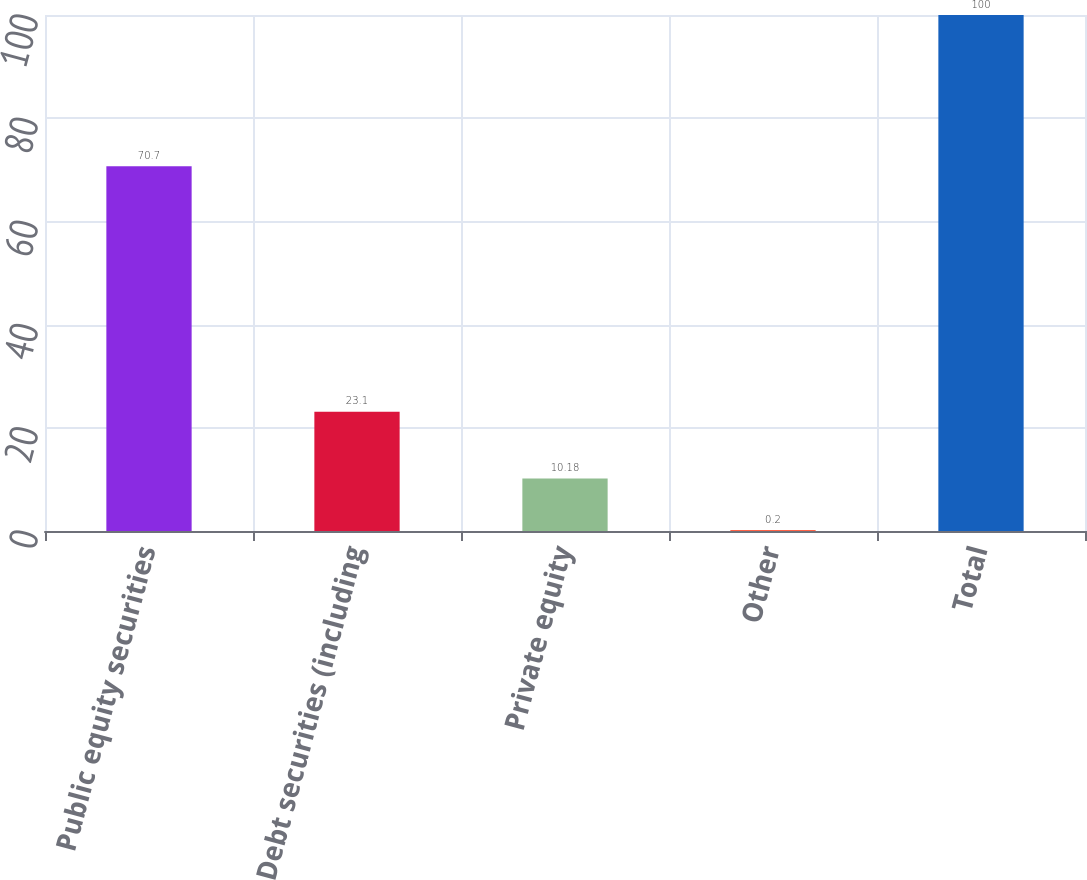Convert chart to OTSL. <chart><loc_0><loc_0><loc_500><loc_500><bar_chart><fcel>Public equity securities<fcel>Debt securities (including<fcel>Private equity<fcel>Other<fcel>Total<nl><fcel>70.7<fcel>23.1<fcel>10.18<fcel>0.2<fcel>100<nl></chart> 